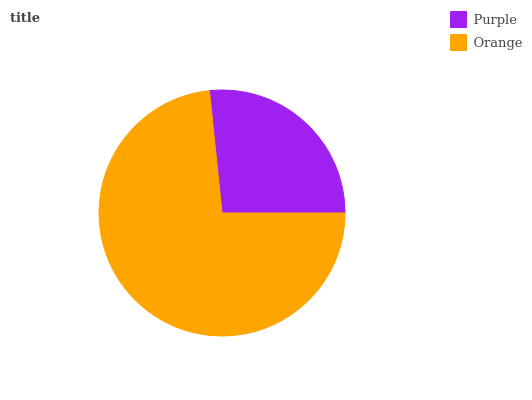Is Purple the minimum?
Answer yes or no. Yes. Is Orange the maximum?
Answer yes or no. Yes. Is Orange the minimum?
Answer yes or no. No. Is Orange greater than Purple?
Answer yes or no. Yes. Is Purple less than Orange?
Answer yes or no. Yes. Is Purple greater than Orange?
Answer yes or no. No. Is Orange less than Purple?
Answer yes or no. No. Is Orange the high median?
Answer yes or no. Yes. Is Purple the low median?
Answer yes or no. Yes. Is Purple the high median?
Answer yes or no. No. Is Orange the low median?
Answer yes or no. No. 